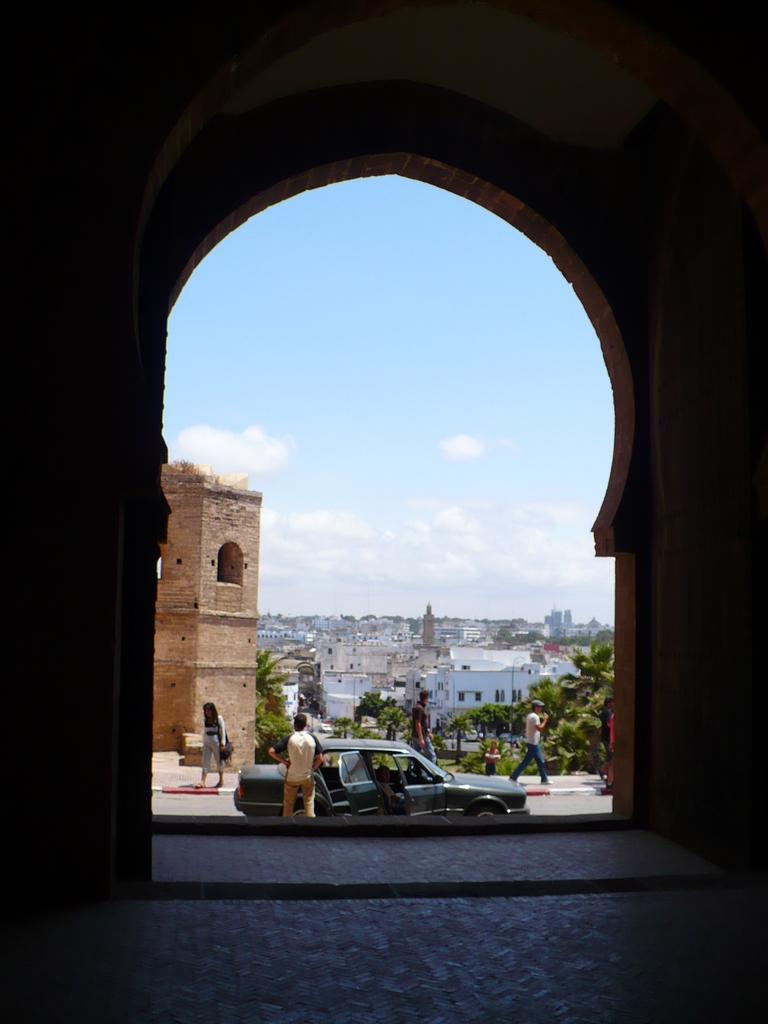What structure is present in the image? There is an arch in the image. What can be seen beyond the arch? Buildings are visible through the arch. What type of vegetation is present in the image? There are trees in the image. What are some of the people in the image doing? Some people are walking, and others are standing in the image. What type of vehicle is present in the image? There is a car in the image. How would you describe the sky in the image? The sky is blue and cloudy. What type of apparel is the tree wearing in the image? Trees do not wear apparel, so this question cannot be answered. Can you see a rake being used by someone in the image? There is no rake present in the image. 